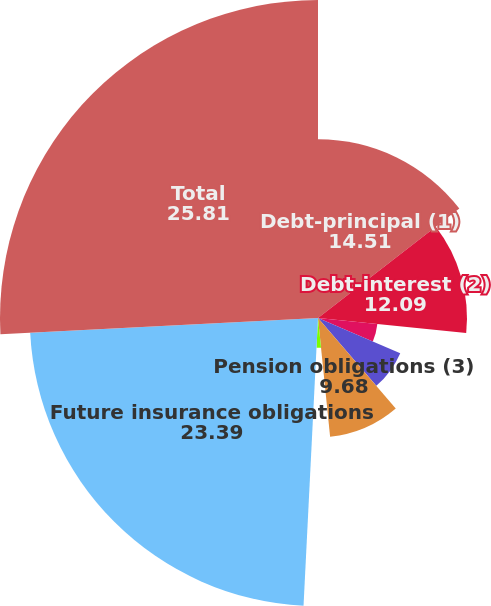Convert chart to OTSL. <chart><loc_0><loc_0><loc_500><loc_500><pie_chart><fcel>Debt-principal (1)<fcel>Debt-interest (2)<fcel>Capital leases<fcel>Operating leases<fcel>Purchase obligations<fcel>Pension obligations (3)<fcel>Uncertain tax positions (4)<fcel>Future insurance obligations<fcel>Total<nl><fcel>14.51%<fcel>12.09%<fcel>4.84%<fcel>7.26%<fcel>0.0%<fcel>9.68%<fcel>2.42%<fcel>23.39%<fcel>25.81%<nl></chart> 